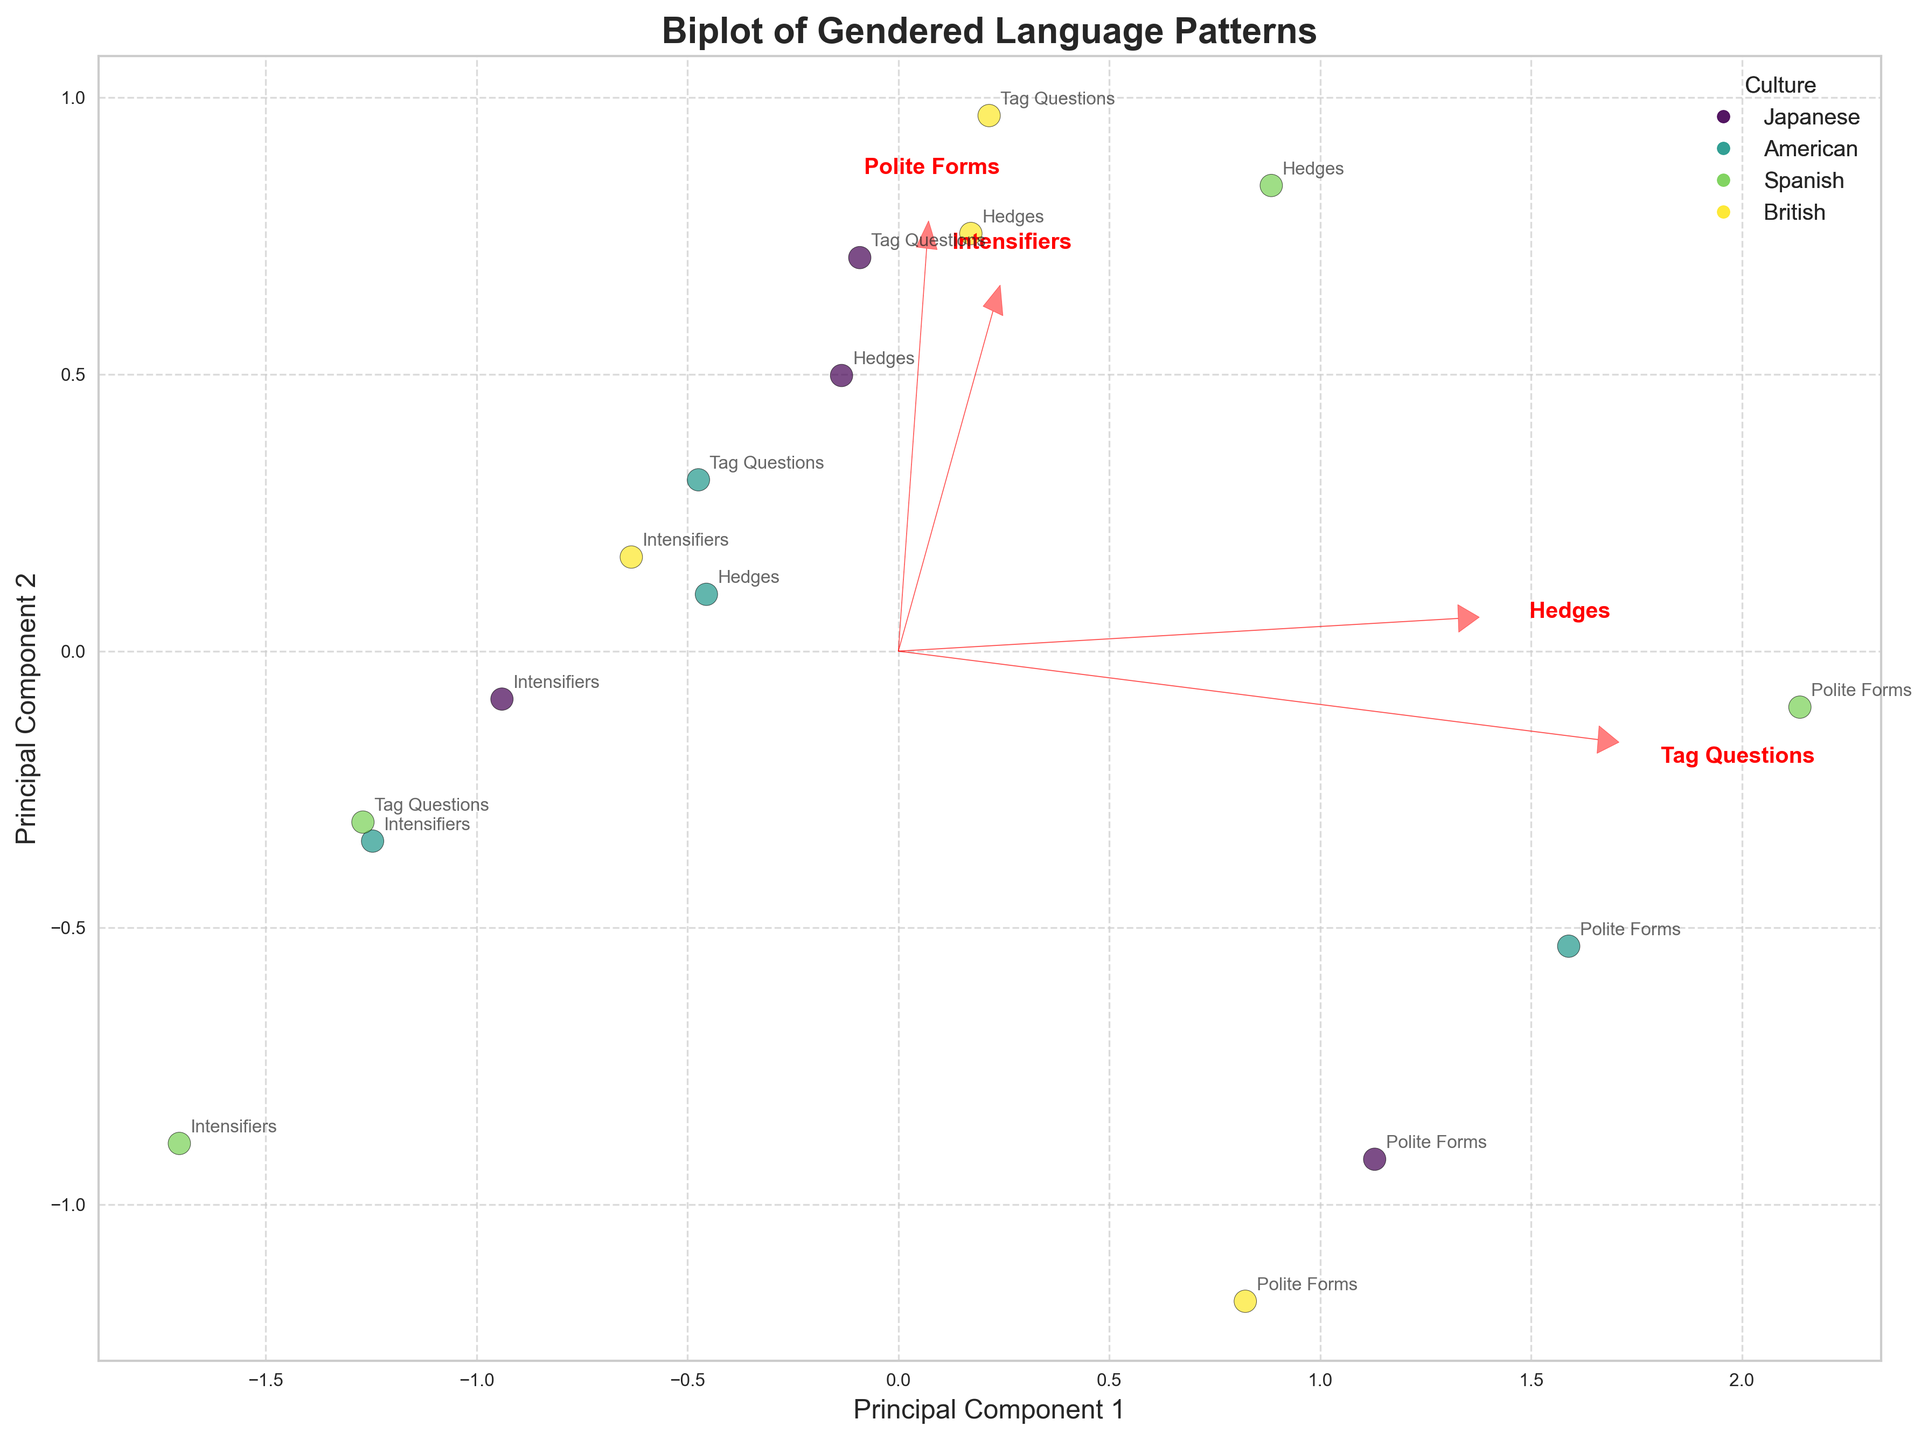What is the title of the figure? The title is typically prominently displayed at the top of the figure and summarizes the primary focus of the plot.
Answer: Biplot of Gendered Language Patterns Which principal component explains more variance in the data? From the labels of the axes, we can determine which principal component explains more of the variance. The one labeled "Principal Component 1" or "Principal Component 2" with a larger percentage would explain more variance.
Answer: Principal Component 1 How many different cultures are represented in the scatter plot? By referring to the legend, which categorizes the data points based on culture, we can count the distinct categories listed.
Answer: Four Which language feature has the longest vector in the biplot? The vector lengths are represented as arrows in the biplot. The longest arrowhead at the furthest distance from (0,0) indicates the longest vector.
Answer: Polite Forms What can you infer about "Polite Forms" based on the biplot? By looking at the direction and length of the arrow for "Polite Forms," we can infer that it has a strong influence on the variance captured by the principal components.
Answer: Strong influence Which culture group exhibits the most significant spread in the data points? By looking at the scatter plot, we can observe which culture's data points are most widely dispersed.
Answer: American What is the overall trend for Intensifiers in formal vs. informal communication styles across all cultures? By analyzing the vectors' directions and lengths for "Intensifiers," we can observe their overall influence in formal versus informal modes.
Answer: More prevalent in informal Do males or females use more tag questions in informal communication styles as observed in the plot? By examining the scatter plot and the vectors, we can compare the data points related to informal male and female usage of tag questions.
Answer: Females Which principal component likely relates more to informal communication styles? By identifying which principal component has strong correlations with features that are predominantly observed in informal communication styles, we can deduce its significance.
Answer: Principal Component 2 How do Japanese and British cultures compare in the use of hedges in informal communication? By locating the data points for Japanese and British cultures and comparing their loadings on the informal axis for "hedges," we can make a comparison.
Answer: Japanese higher 